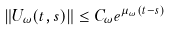Convert formula to latex. <formula><loc_0><loc_0><loc_500><loc_500>\| U _ { \omega } ( t , s ) \| \leq C _ { \omega } e ^ { \mu _ { \omega } ( t - s ) }</formula> 